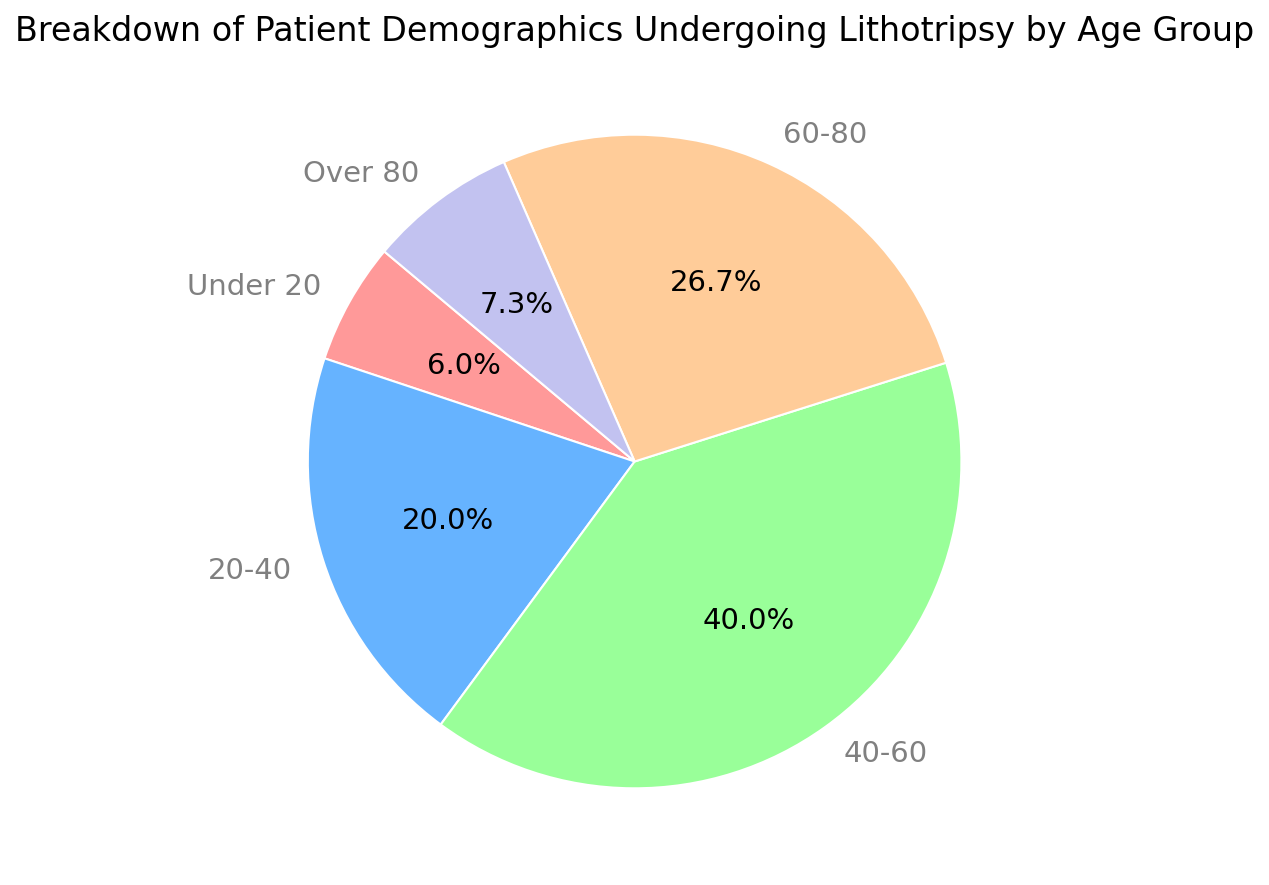Which age group has the highest percentage of patients undergoing lithotripsy? The highest percentage can be identified by looking at the age group with the largest pie slice. The group 40-60 has the largest slice at 42.9%.
Answer: 40-60 Which two age groups together make up more than half of the patients? Calculate the sum of the percentages for each age group and identify the two groups that collectively exceed 50%. The 40-60 group (42.9%) and the 20-40 group (21.4%) together make up 64.3%.
Answer: 40-60 and 20-40 What is the total percentage of patients who are either under 20 or over 80? Add the percentages of the Under 20 group (6.4%) and the Over 80 group (7.9%). 6.4% + 7.9% = 14.3%.
Answer: 14.3% How does the number of patients in the 60-80 age group compare to the number of patients in the 40-60 age group? The pie chart shows that the 40-60 age group accounts for 42.9%, and the 60-80 age group accounts for 28.6%. Because 42.9% is greater than 28.6%, the 40-60 age group has more patients.
Answer: 40-60 group has more patients Which age group has the smallest proportion of patients, and what is that percentage? Identify the smallest pie slice, which corresponds to the Under 20 age group, representing 6.4% of patients.
Answer: Under 20, 6.4% What is the combined percentage of patients aged between 20 and 60 years old? Add the percentages of the 20-40 group (21.4%) and the 40-60 group (42.9%). 21.4% + 42.9% = 64.3%.
Answer: 64.3% If the total number of patients undergoing lithotripsy is 750, how many patients are in the 20-40 age group? Multiply the total number of patients (750) by the percentage of the 20-40 age group (21.4%). 750 * 0.214 = 160.5, which rounds to 161 patients.
Answer: 161 How many more patients are there in the 40-60 age group compared to the Under 20 age group? Subtract the number of patients in the Under 20 age group (45) from the number of patients in the 40-60 age group (300). 300 - 45 = 255.
Answer: 255 Compare the color of the wedge representing the 60-80 age group to the color of the wedge representing the Over 80 group. Visually inspect the pie chart where the 60-80 age group is represented in orange, and the Over 80 group is represented in purple.
Answer: 60-80 is orange, Over 80 is purple What proportion of patients are 60 years old or older? Add the percentages of the 60-80 group (28.6%) and the Over 80 group (7.9%). 28.6% + 7.9% = 36.5%.
Answer: 36.5% 